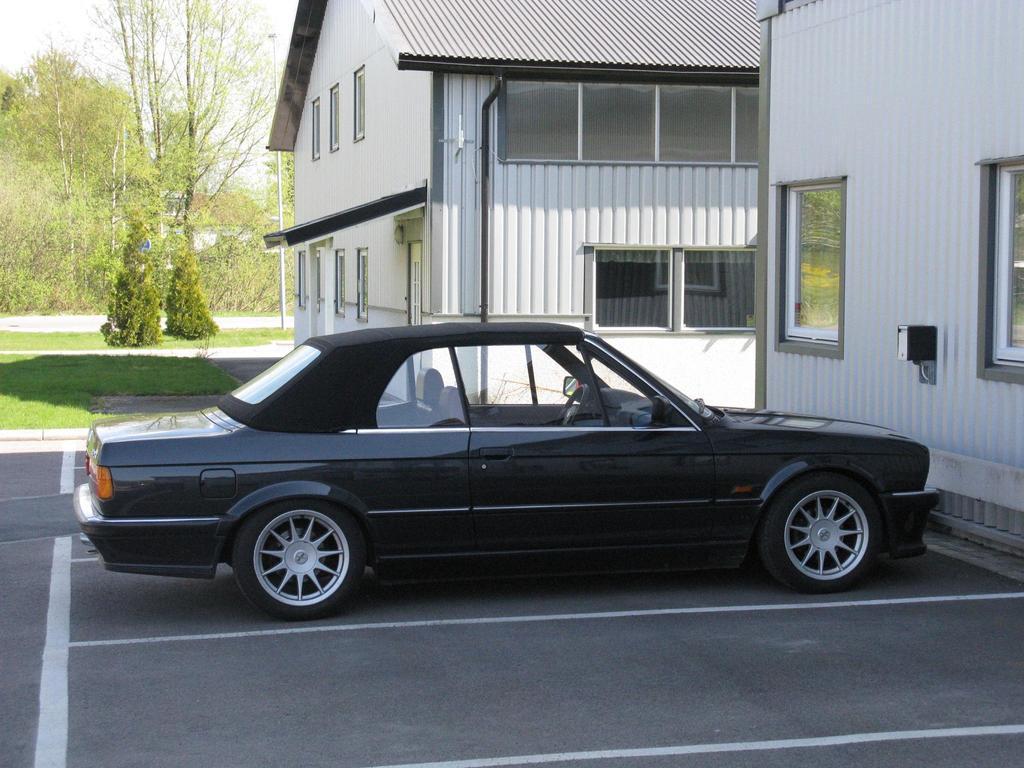In one or two sentences, can you explain what this image depicts? Here in this picture we can see a black colored car present on the road and in front of that we can see houses present and we can also see windows and doors also present on it and we can see some part of ground is covered with grass and we can also see plants and trees present and we can see the sky is cloudy. 